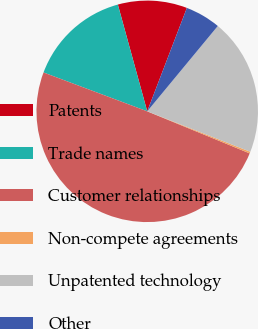<chart> <loc_0><loc_0><loc_500><loc_500><pie_chart><fcel>Patents<fcel>Trade names<fcel>Customer relationships<fcel>Non-compete agreements<fcel>Unpatented technology<fcel>Other<nl><fcel>10.1%<fcel>15.02%<fcel>49.5%<fcel>0.25%<fcel>19.95%<fcel>5.17%<nl></chart> 